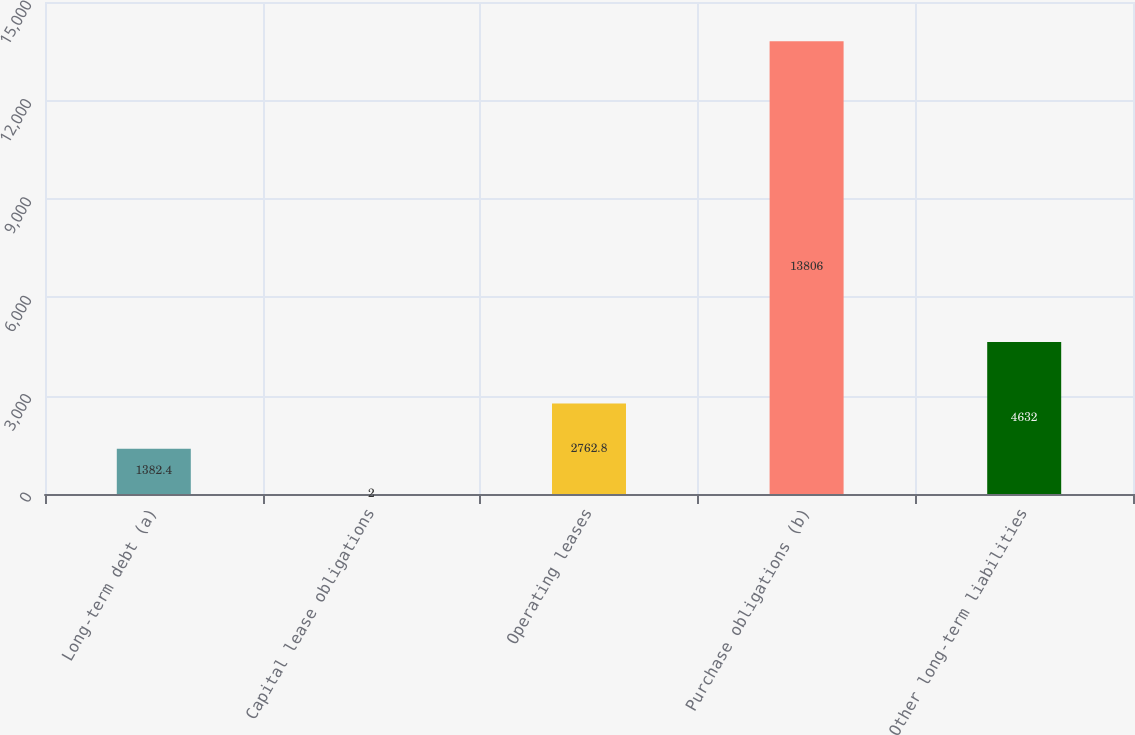Convert chart to OTSL. <chart><loc_0><loc_0><loc_500><loc_500><bar_chart><fcel>Long-term debt (a)<fcel>Capital lease obligations<fcel>Operating leases<fcel>Purchase obligations (b)<fcel>Other long-term liabilities<nl><fcel>1382.4<fcel>2<fcel>2762.8<fcel>13806<fcel>4632<nl></chart> 